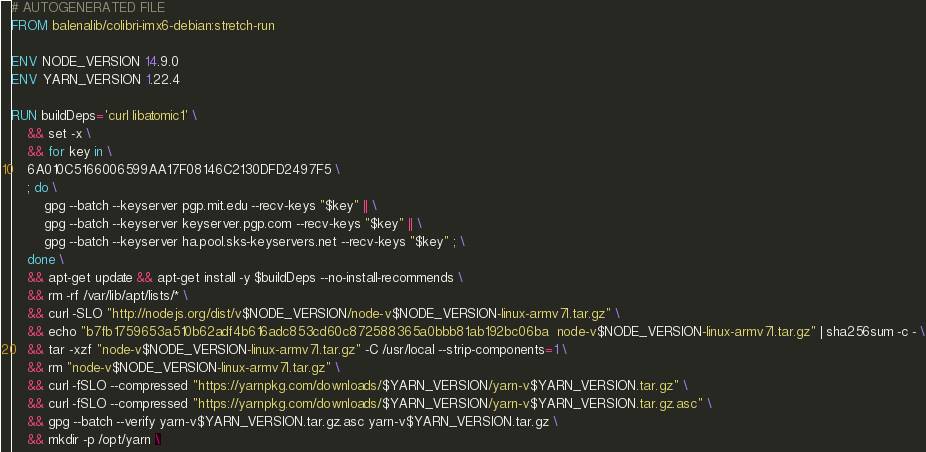<code> <loc_0><loc_0><loc_500><loc_500><_Dockerfile_># AUTOGENERATED FILE
FROM balenalib/colibri-imx6-debian:stretch-run

ENV NODE_VERSION 14.9.0
ENV YARN_VERSION 1.22.4

RUN buildDeps='curl libatomic1' \
	&& set -x \
	&& for key in \
	6A010C5166006599AA17F08146C2130DFD2497F5 \
	; do \
		gpg --batch --keyserver pgp.mit.edu --recv-keys "$key" || \
		gpg --batch --keyserver keyserver.pgp.com --recv-keys "$key" || \
		gpg --batch --keyserver ha.pool.sks-keyservers.net --recv-keys "$key" ; \
	done \
	&& apt-get update && apt-get install -y $buildDeps --no-install-recommends \
	&& rm -rf /var/lib/apt/lists/* \
	&& curl -SLO "http://nodejs.org/dist/v$NODE_VERSION/node-v$NODE_VERSION-linux-armv7l.tar.gz" \
	&& echo "b7fb1759653a510b62adf4b616adc853cd60c872588365a0bbb81ab192bc06ba  node-v$NODE_VERSION-linux-armv7l.tar.gz" | sha256sum -c - \
	&& tar -xzf "node-v$NODE_VERSION-linux-armv7l.tar.gz" -C /usr/local --strip-components=1 \
	&& rm "node-v$NODE_VERSION-linux-armv7l.tar.gz" \
	&& curl -fSLO --compressed "https://yarnpkg.com/downloads/$YARN_VERSION/yarn-v$YARN_VERSION.tar.gz" \
	&& curl -fSLO --compressed "https://yarnpkg.com/downloads/$YARN_VERSION/yarn-v$YARN_VERSION.tar.gz.asc" \
	&& gpg --batch --verify yarn-v$YARN_VERSION.tar.gz.asc yarn-v$YARN_VERSION.tar.gz \
	&& mkdir -p /opt/yarn \</code> 